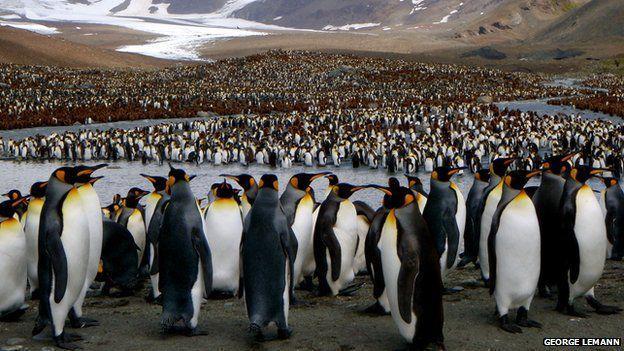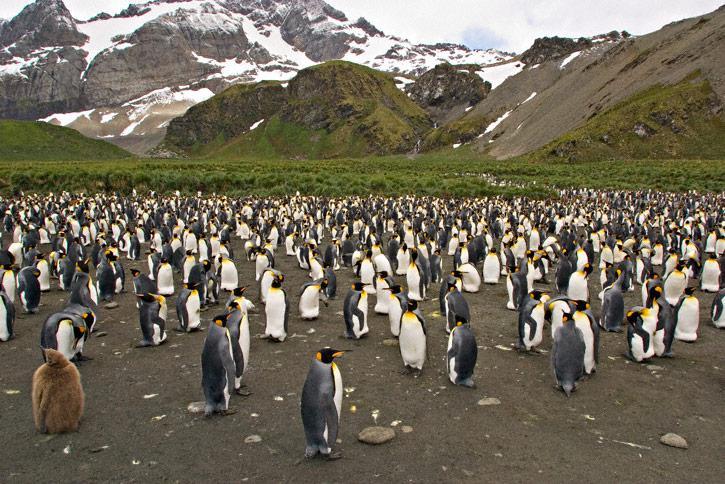The first image is the image on the left, the second image is the image on the right. For the images displayed, is the sentence "At least one fuzzy brown chick is present." factually correct? Answer yes or no. Yes. The first image is the image on the left, the second image is the image on the right. For the images shown, is this caption "A brown-feathered penguin is standing at the front of a mass of penguins." true? Answer yes or no. Yes. The first image is the image on the left, the second image is the image on the right. Evaluate the accuracy of this statement regarding the images: "A penguin is laying flat on the ground amid a big flock of penguins, in one image.". Is it true? Answer yes or no. No. 